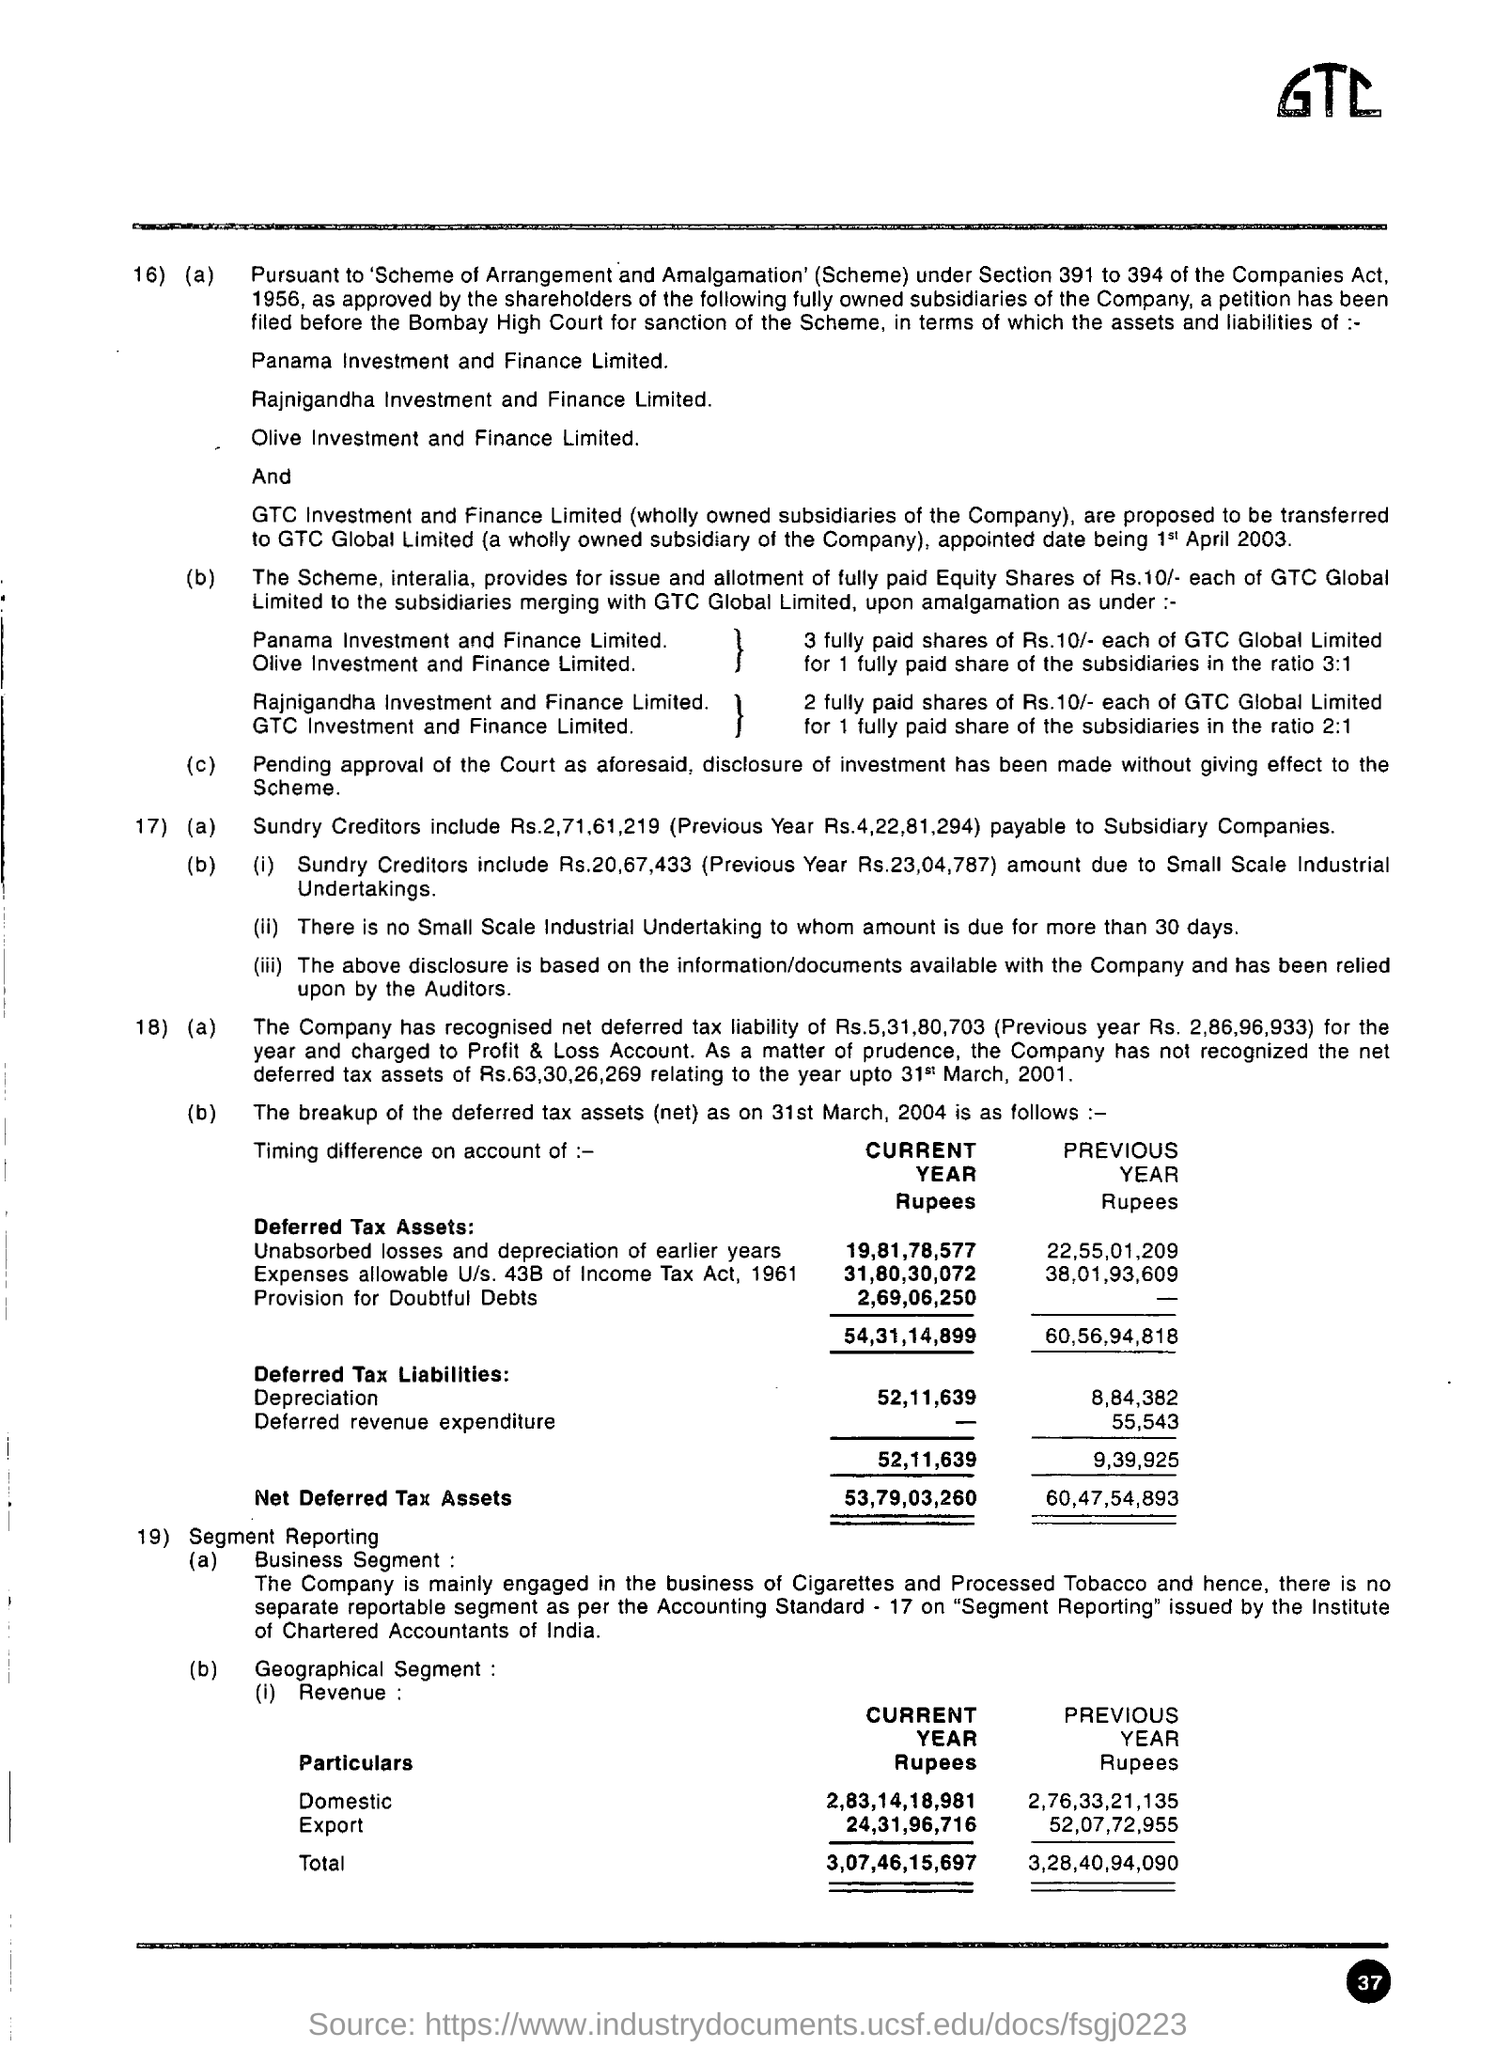Point out several critical features in this image. The text written in the top right corner is 'GTC...' 